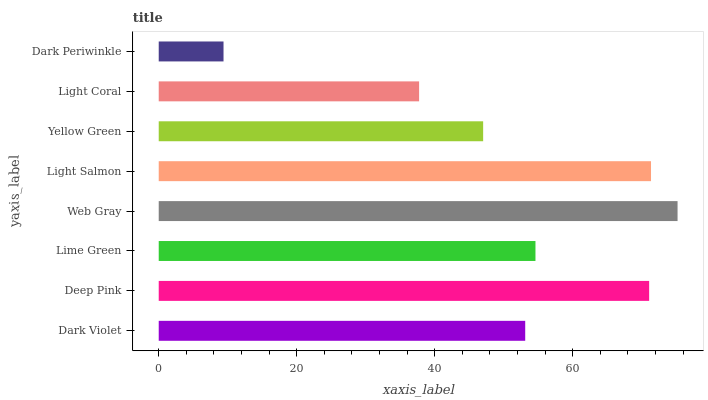Is Dark Periwinkle the minimum?
Answer yes or no. Yes. Is Web Gray the maximum?
Answer yes or no. Yes. Is Deep Pink the minimum?
Answer yes or no. No. Is Deep Pink the maximum?
Answer yes or no. No. Is Deep Pink greater than Dark Violet?
Answer yes or no. Yes. Is Dark Violet less than Deep Pink?
Answer yes or no. Yes. Is Dark Violet greater than Deep Pink?
Answer yes or no. No. Is Deep Pink less than Dark Violet?
Answer yes or no. No. Is Lime Green the high median?
Answer yes or no. Yes. Is Dark Violet the low median?
Answer yes or no. Yes. Is Light Coral the high median?
Answer yes or no. No. Is Light Coral the low median?
Answer yes or no. No. 